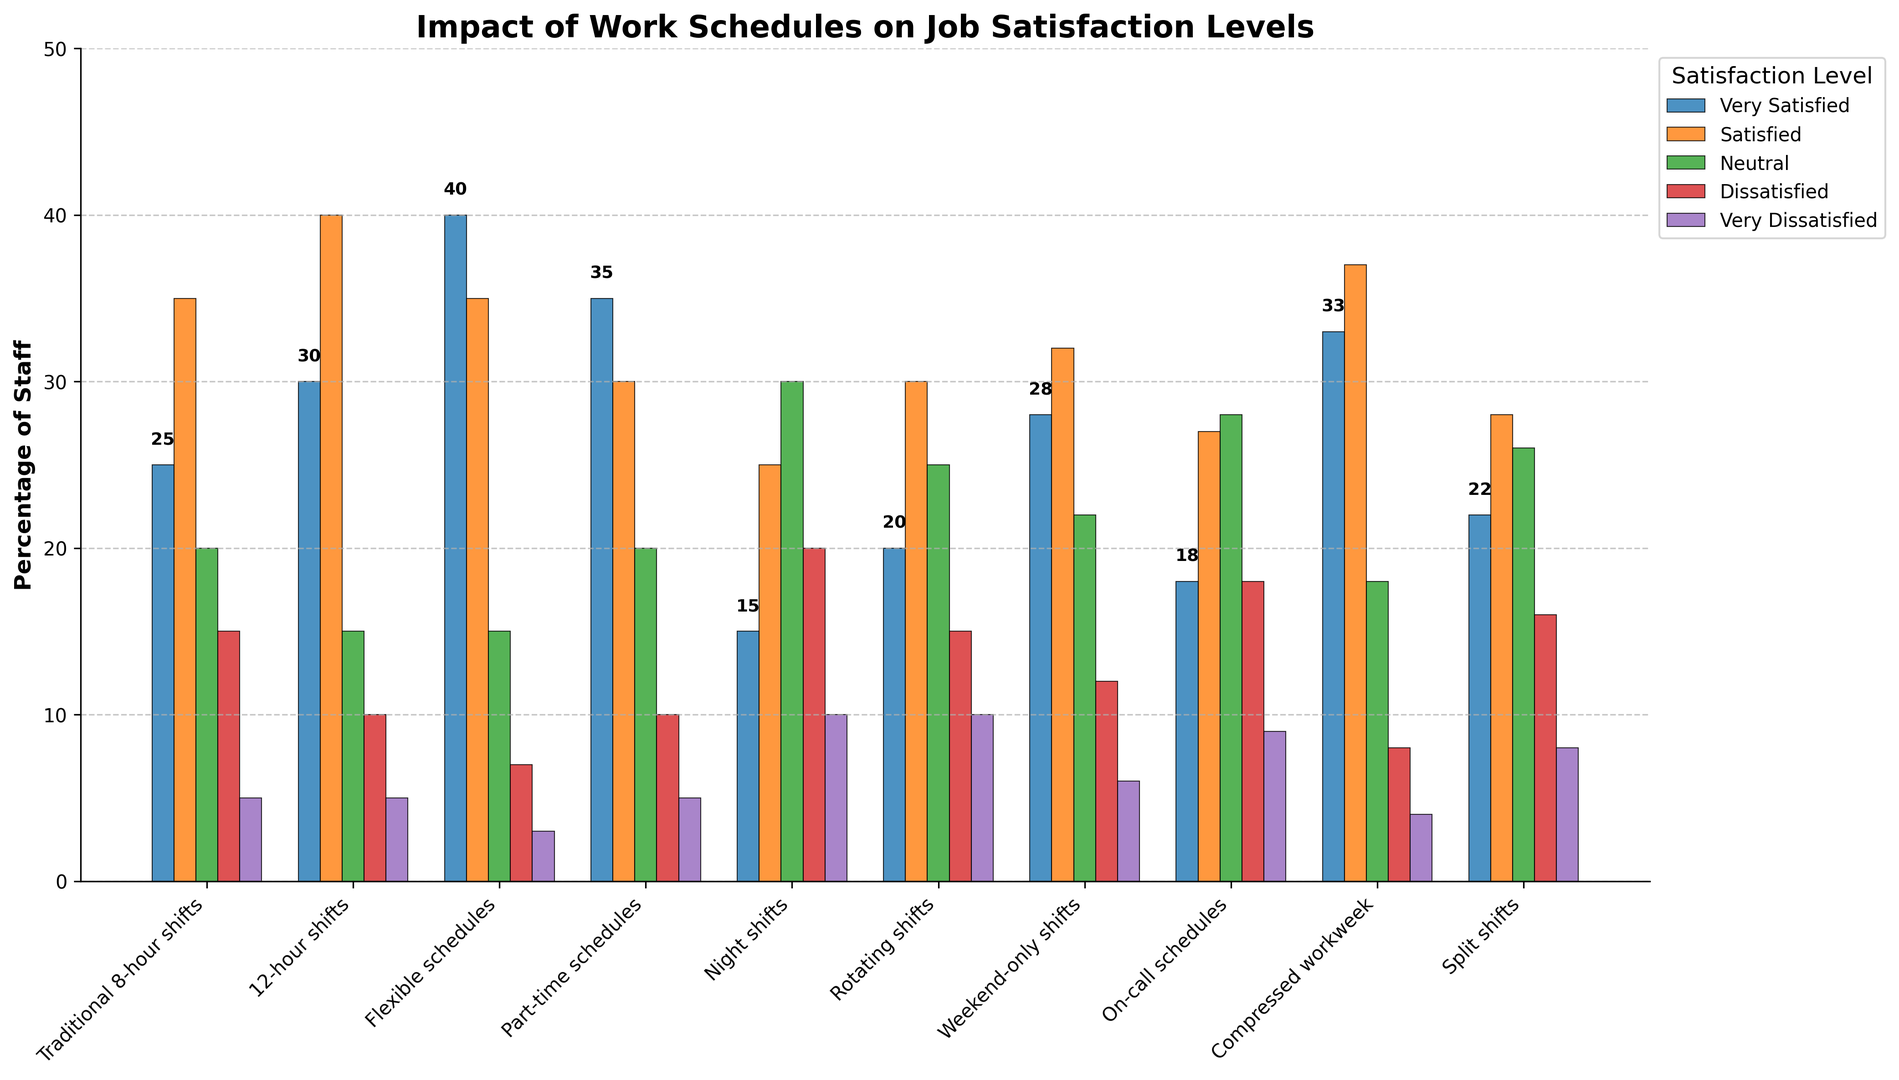Which work schedule has the highest percentage of 'Very Satisfied' staff? The 'Very Satisfied' satisfaction level is represented by the first group of bars. The tallest bar in this group corresponds to 'Flexible schedules.' Therefore, 'Flexible schedules' has the highest percentage of 'Very Satisfied' staff.
Answer: Flexible schedules Which work schedule has the highest percentage of 'Very Dissatisfied' staff? The 'Very Dissatisfied' satisfaction level is the last group of bars. The tallest bar in this group corresponds to 'Night shifts.' Therefore, 'Night shifts' has the highest percentage of 'Very Dissatisfied' staff.
Answer: Night shifts Compare the percentage of 'Satisfied' staff between 'Traditional 8-hour shifts' and '12-hour shifts.' Which one has a higher percentage? The 'Satisfied' satisfaction level is represented by the second group of bars. The height of the bar for '12-hour shifts' is higher than that for 'Traditional 8-hour shifts.' Therefore, '12-hour shifts' have a higher percentage of 'Satisfied' staff.
Answer: 12-hour shifts Which work schedule has a higher combined percentage of 'Very Satisfied' and 'Satisfied' staff: 'Part-time schedules' or 'Compressed workweek'? For 'Part-time schedules,' the combined percentage is 35 (Very Satisfied) + 30 (Satisfied) = 65. For 'Compressed workweek,' the combined percentage is 33 (Very Satisfied) + 37 (Satisfied) = 70. Therefore, 'Compressed workweek' has a higher combined percentage.
Answer: Compressed workweek What is the percentage difference between 'Neutral' staff in 'Weekend-only shifts' and 'Rotating shifts'? 'Weekend-only shifts' have 22% 'Neutral' staff, and 'Rotating shifts' have 25% 'Neutral' staff. The percentage difference is 25 - 22 = 3.
Answer: 3 Which work schedule has the lowest percentage of 'Neutral' staff? The 'Neutral' satisfaction level is represented by the third group of bars. The shortest bar in this group corresponds to 'Flexible schedules.' Therefore, 'Flexible schedules' has the lowest percentage of 'Neutral' staff.
Answer: Flexible schedules What is the average percentage of 'Dissatisfied' staff among 'Night shifts,' 'On-call schedules,' and 'Split shifts'? 'Night shifts' have 20% 'Dissatisfied' staff, 'On-call schedules' have 18%, and 'Split shifts' have 16%. The average is (20 + 18 + 16) / 3 = 18%.
Answer: 18 Compare the overall job satisfaction ('Very Satisfied' + 'Satisfied') between 'Traditional 8-hour shifts' and 'Flexible schedules.' Which one is higher and by how much? For 'Traditional 8-hour shifts,' the combined satisfaction is 25 (Very Satisfied) + 35 (Satisfied) = 60. For 'Flexible schedules,' the combined satisfaction is 40 (Very Satisfied) + 35 (Satisfied) = 75. The difference is 75 - 60 = 15. Therefore, 'Flexible schedules' have a higher overall job satisfaction by 15.
Answer: Flexible schedules by 15 Which work schedule has the smallest percentage range between 'Very Satisfied' and 'Very Dissatisfied' staff? Calculating the range for each schedule, the smallest range is for 'Flexible schedules' (40 - 3 = 37). Therefore, 'Flexible schedules' have the smallest percentage range.
Answer: Flexible schedules Which work schedule shows the largest disparity between 'Satisfied' and 'Dissatisfied' staff? Calculating the disparity for each schedule, 'Flexible schedules' (35 - 7 = 28) and '12-hour shifts' (40 - 10 = 30), the largest disparity is for '12-hour shifts' at 30. Therefore, '12-hour shifts' show the largest disparity.
Answer: 12-hour shifts 